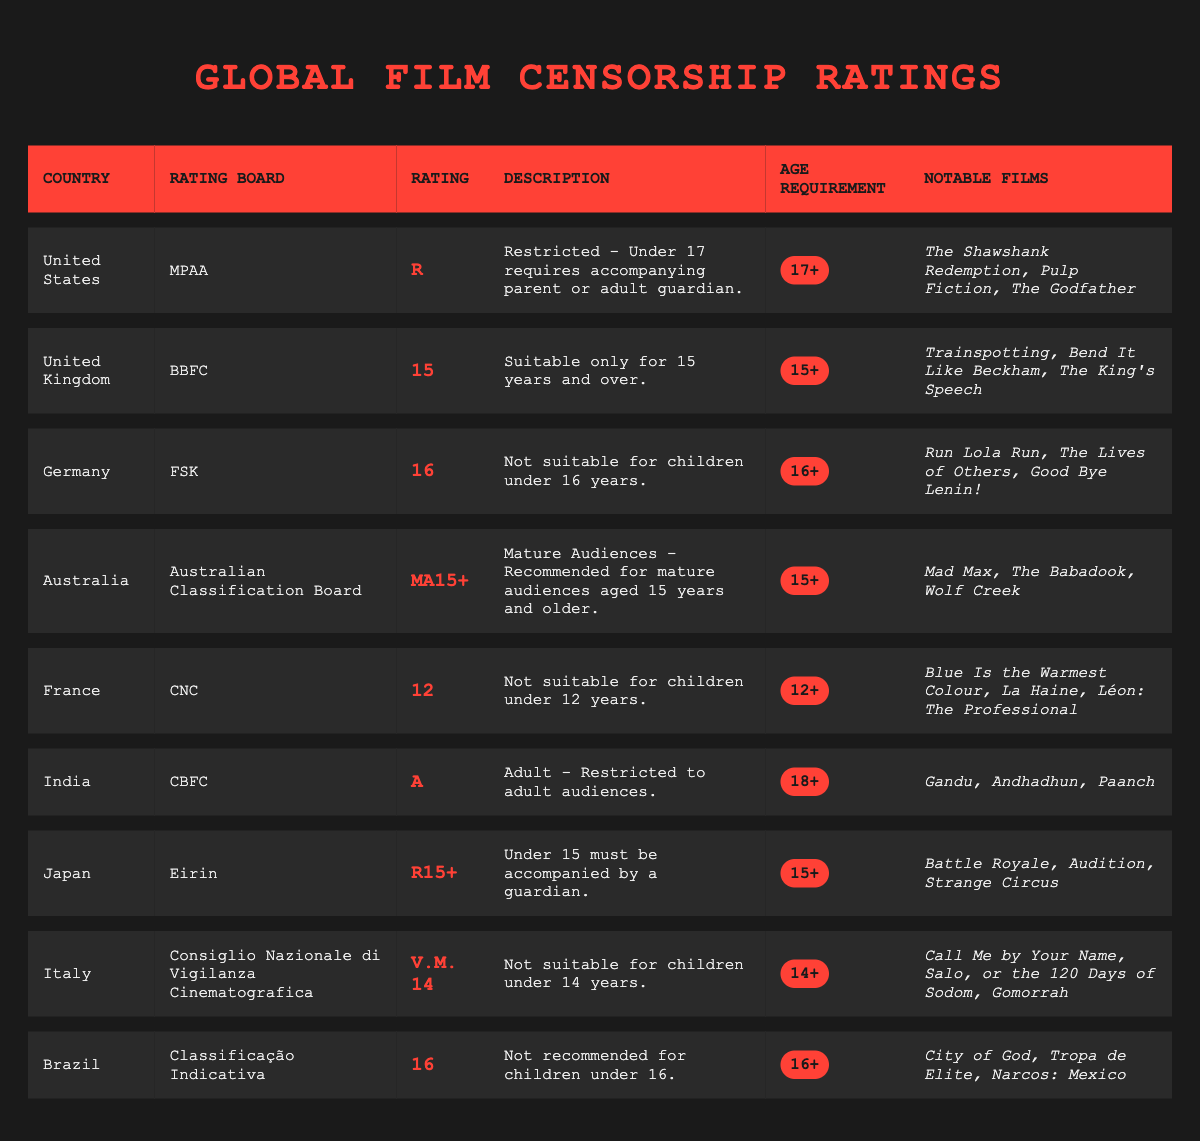What is the rating for films in Germany? The table indicates that the rating for films in Germany is "16".
Answer: 16 What are the notable films listed for the United Kingdom? The remarkable films from the United Kingdom as per the table are "Trainspotting", "Bend It Like Beckham", and "The King's Speech".
Answer: Trainspotting, Bend It Like Beckham, The King's Speech Which country has a rating board named Eirin? According to the table, Japan has a rating board named Eirin.
Answer: Japan Is the age requirement for films rated A in India 15+? The age requirement for films rated A in India is "18+", which means films are restricted to adult audiences and thus the answer is false.
Answer: No How many countries have a rating of 16 or higher? From the table, Germany, Brazil, and Australia have ratings of 16 or higher. There are three countries meeting this criterion.
Answer: 3 What is the difference in age requirements between films rated R in the United States and films rated R15+ in Japan? In the United States, the age requirement for R-rated films is 17+, while for R15+ films in Japan, it is 15+. Thus, the difference in age requirements is 2 years (17 - 15 = 2).
Answer: 2 Are films rated MA15+ in Australia suitable for audiences aged 14? The age requirement for films rated MA15+ in Australia is "15+", which means they are not suitable for audiences aged 14.
Answer: No Which country requires that individuals under 15 must be accompanied by a guardian when viewing films? The table shows that Japan requires that individuals under 15 must be accompanied by a guardian for films rated R15+.
Answer: Japan 